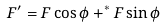Convert formula to latex. <formula><loc_0><loc_0><loc_500><loc_500>F ^ { \prime } = F \cos \phi + ^ { * } F \sin \phi</formula> 